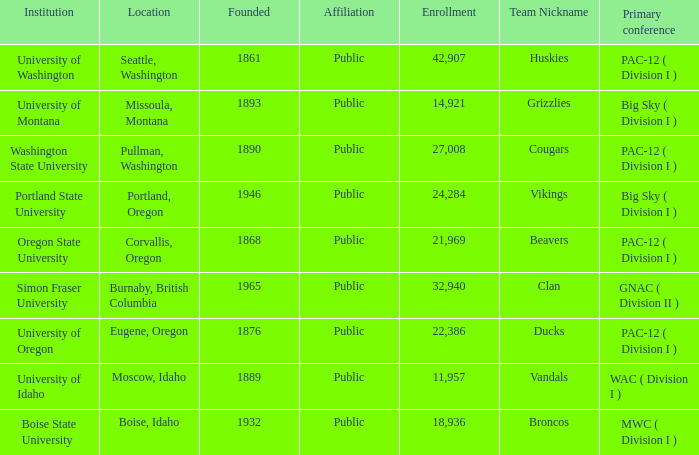What is the location of the University of Montana, which was founded after 1890? Missoula, Montana. Parse the full table. {'header': ['Institution', 'Location', 'Founded', 'Affiliation', 'Enrollment', 'Team Nickname', 'Primary conference'], 'rows': [['University of Washington', 'Seattle, Washington', '1861', 'Public', '42,907', 'Huskies', 'PAC-12 ( Division I )'], ['University of Montana', 'Missoula, Montana', '1893', 'Public', '14,921', 'Grizzlies', 'Big Sky ( Division I )'], ['Washington State University', 'Pullman, Washington', '1890', 'Public', '27,008', 'Cougars', 'PAC-12 ( Division I )'], ['Portland State University', 'Portland, Oregon', '1946', 'Public', '24,284', 'Vikings', 'Big Sky ( Division I )'], ['Oregon State University', 'Corvallis, Oregon', '1868', 'Public', '21,969', 'Beavers', 'PAC-12 ( Division I )'], ['Simon Fraser University', 'Burnaby, British Columbia', '1965', 'Public', '32,940', 'Clan', 'GNAC ( Division II )'], ['University of Oregon', 'Eugene, Oregon', '1876', 'Public', '22,386', 'Ducks', 'PAC-12 ( Division I )'], ['University of Idaho', 'Moscow, Idaho', '1889', 'Public', '11,957', 'Vandals', 'WAC ( Division I )'], ['Boise State University', 'Boise, Idaho', '1932', 'Public', '18,936', 'Broncos', 'MWC ( Division I )']]} 